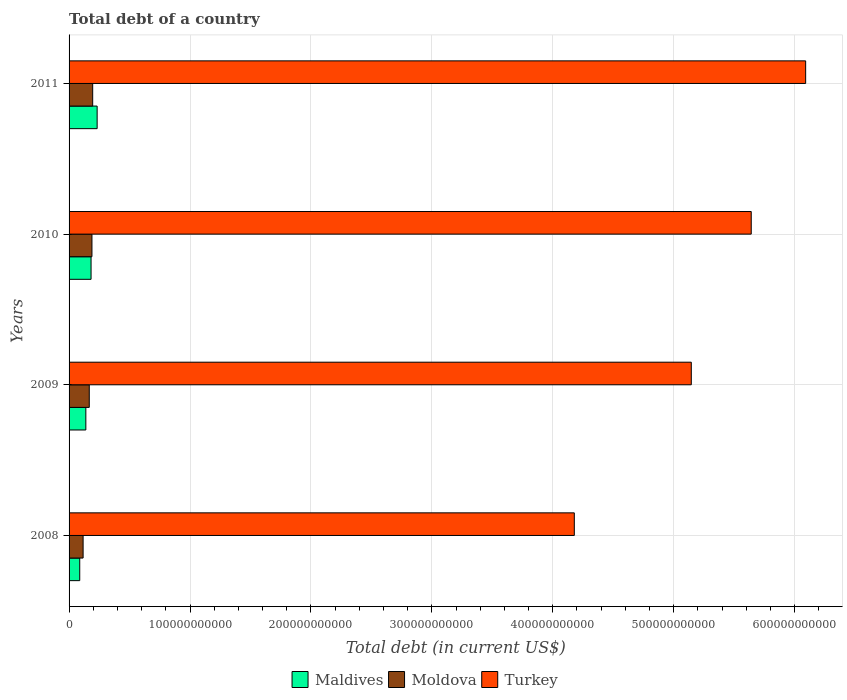How many different coloured bars are there?
Your answer should be very brief. 3. Are the number of bars per tick equal to the number of legend labels?
Make the answer very short. Yes. Are the number of bars on each tick of the Y-axis equal?
Provide a short and direct response. Yes. How many bars are there on the 4th tick from the top?
Make the answer very short. 3. How many bars are there on the 2nd tick from the bottom?
Your answer should be compact. 3. In how many cases, is the number of bars for a given year not equal to the number of legend labels?
Provide a succinct answer. 0. What is the debt in Maldives in 2010?
Offer a very short reply. 1.82e+1. Across all years, what is the maximum debt in Turkey?
Provide a short and direct response. 6.09e+11. Across all years, what is the minimum debt in Maldives?
Provide a succinct answer. 8.82e+09. What is the total debt in Maldives in the graph?
Ensure brevity in your answer.  6.41e+1. What is the difference between the debt in Moldova in 2008 and that in 2011?
Your answer should be compact. -7.92e+09. What is the difference between the debt in Moldova in 2009 and the debt in Turkey in 2011?
Provide a short and direct response. -5.92e+11. What is the average debt in Maldives per year?
Your answer should be very brief. 1.60e+1. In the year 2011, what is the difference between the debt in Maldives and debt in Turkey?
Give a very brief answer. -5.86e+11. What is the ratio of the debt in Maldives in 2008 to that in 2010?
Your answer should be very brief. 0.49. What is the difference between the highest and the second highest debt in Turkey?
Your response must be concise. 4.50e+1. What is the difference between the highest and the lowest debt in Maldives?
Ensure brevity in your answer.  1.44e+1. In how many years, is the debt in Turkey greater than the average debt in Turkey taken over all years?
Provide a short and direct response. 2. Is the sum of the debt in Maldives in 2008 and 2011 greater than the maximum debt in Moldova across all years?
Give a very brief answer. Yes. What does the 3rd bar from the top in 2009 represents?
Make the answer very short. Maldives. What does the 2nd bar from the bottom in 2008 represents?
Offer a terse response. Moldova. Is it the case that in every year, the sum of the debt in Moldova and debt in Maldives is greater than the debt in Turkey?
Offer a terse response. No. How many bars are there?
Your answer should be very brief. 12. Are all the bars in the graph horizontal?
Your answer should be very brief. Yes. What is the difference between two consecutive major ticks on the X-axis?
Your answer should be very brief. 1.00e+11. How are the legend labels stacked?
Provide a succinct answer. Horizontal. What is the title of the graph?
Make the answer very short. Total debt of a country. What is the label or title of the X-axis?
Provide a short and direct response. Total debt (in current US$). What is the Total debt (in current US$) in Maldives in 2008?
Make the answer very short. 8.82e+09. What is the Total debt (in current US$) of Moldova in 2008?
Ensure brevity in your answer.  1.16e+1. What is the Total debt (in current US$) in Turkey in 2008?
Your response must be concise. 4.18e+11. What is the Total debt (in current US$) in Maldives in 2009?
Keep it short and to the point. 1.39e+1. What is the Total debt (in current US$) in Moldova in 2009?
Make the answer very short. 1.67e+1. What is the Total debt (in current US$) in Turkey in 2009?
Provide a short and direct response. 5.15e+11. What is the Total debt (in current US$) of Maldives in 2010?
Your answer should be compact. 1.82e+1. What is the Total debt (in current US$) of Moldova in 2010?
Provide a short and direct response. 1.89e+1. What is the Total debt (in current US$) in Turkey in 2010?
Your response must be concise. 5.64e+11. What is the Total debt (in current US$) in Maldives in 2011?
Offer a terse response. 2.32e+1. What is the Total debt (in current US$) of Moldova in 2011?
Your answer should be compact. 1.95e+1. What is the Total debt (in current US$) of Turkey in 2011?
Make the answer very short. 6.09e+11. Across all years, what is the maximum Total debt (in current US$) of Maldives?
Offer a terse response. 2.32e+1. Across all years, what is the maximum Total debt (in current US$) of Moldova?
Ensure brevity in your answer.  1.95e+1. Across all years, what is the maximum Total debt (in current US$) of Turkey?
Offer a terse response. 6.09e+11. Across all years, what is the minimum Total debt (in current US$) in Maldives?
Offer a terse response. 8.82e+09. Across all years, what is the minimum Total debt (in current US$) of Moldova?
Keep it short and to the point. 1.16e+1. Across all years, what is the minimum Total debt (in current US$) in Turkey?
Your answer should be compact. 4.18e+11. What is the total Total debt (in current US$) of Maldives in the graph?
Your answer should be very brief. 6.41e+1. What is the total Total debt (in current US$) of Moldova in the graph?
Ensure brevity in your answer.  6.67e+1. What is the total Total debt (in current US$) in Turkey in the graph?
Your answer should be compact. 2.11e+12. What is the difference between the Total debt (in current US$) of Maldives in 2008 and that in 2009?
Make the answer very short. -5.04e+09. What is the difference between the Total debt (in current US$) in Moldova in 2008 and that in 2009?
Provide a short and direct response. -5.09e+09. What is the difference between the Total debt (in current US$) in Turkey in 2008 and that in 2009?
Give a very brief answer. -9.67e+1. What is the difference between the Total debt (in current US$) of Maldives in 2008 and that in 2010?
Give a very brief answer. -9.36e+09. What is the difference between the Total debt (in current US$) in Moldova in 2008 and that in 2010?
Ensure brevity in your answer.  -7.32e+09. What is the difference between the Total debt (in current US$) in Turkey in 2008 and that in 2010?
Provide a short and direct response. -1.46e+11. What is the difference between the Total debt (in current US$) of Maldives in 2008 and that in 2011?
Give a very brief answer. -1.44e+1. What is the difference between the Total debt (in current US$) of Moldova in 2008 and that in 2011?
Your answer should be compact. -7.92e+09. What is the difference between the Total debt (in current US$) in Turkey in 2008 and that in 2011?
Keep it short and to the point. -1.91e+11. What is the difference between the Total debt (in current US$) of Maldives in 2009 and that in 2010?
Ensure brevity in your answer.  -4.32e+09. What is the difference between the Total debt (in current US$) of Moldova in 2009 and that in 2010?
Provide a short and direct response. -2.22e+09. What is the difference between the Total debt (in current US$) of Turkey in 2009 and that in 2010?
Offer a terse response. -4.96e+1. What is the difference between the Total debt (in current US$) of Maldives in 2009 and that in 2011?
Your response must be concise. -9.34e+09. What is the difference between the Total debt (in current US$) in Moldova in 2009 and that in 2011?
Provide a short and direct response. -2.83e+09. What is the difference between the Total debt (in current US$) of Turkey in 2009 and that in 2011?
Give a very brief answer. -9.46e+1. What is the difference between the Total debt (in current US$) in Maldives in 2010 and that in 2011?
Your response must be concise. -5.03e+09. What is the difference between the Total debt (in current US$) in Moldova in 2010 and that in 2011?
Your answer should be very brief. -6.02e+08. What is the difference between the Total debt (in current US$) of Turkey in 2010 and that in 2011?
Your response must be concise. -4.50e+1. What is the difference between the Total debt (in current US$) in Maldives in 2008 and the Total debt (in current US$) in Moldova in 2009?
Make the answer very short. -7.88e+09. What is the difference between the Total debt (in current US$) of Maldives in 2008 and the Total debt (in current US$) of Turkey in 2009?
Offer a terse response. -5.06e+11. What is the difference between the Total debt (in current US$) in Moldova in 2008 and the Total debt (in current US$) in Turkey in 2009?
Your answer should be very brief. -5.03e+11. What is the difference between the Total debt (in current US$) in Maldives in 2008 and the Total debt (in current US$) in Moldova in 2010?
Offer a terse response. -1.01e+1. What is the difference between the Total debt (in current US$) in Maldives in 2008 and the Total debt (in current US$) in Turkey in 2010?
Your answer should be compact. -5.55e+11. What is the difference between the Total debt (in current US$) in Moldova in 2008 and the Total debt (in current US$) in Turkey in 2010?
Keep it short and to the point. -5.53e+11. What is the difference between the Total debt (in current US$) of Maldives in 2008 and the Total debt (in current US$) of Moldova in 2011?
Ensure brevity in your answer.  -1.07e+1. What is the difference between the Total debt (in current US$) in Maldives in 2008 and the Total debt (in current US$) in Turkey in 2011?
Ensure brevity in your answer.  -6.00e+11. What is the difference between the Total debt (in current US$) in Moldova in 2008 and the Total debt (in current US$) in Turkey in 2011?
Provide a succinct answer. -5.98e+11. What is the difference between the Total debt (in current US$) in Maldives in 2009 and the Total debt (in current US$) in Moldova in 2010?
Your response must be concise. -5.06e+09. What is the difference between the Total debt (in current US$) of Maldives in 2009 and the Total debt (in current US$) of Turkey in 2010?
Keep it short and to the point. -5.50e+11. What is the difference between the Total debt (in current US$) in Moldova in 2009 and the Total debt (in current US$) in Turkey in 2010?
Offer a very short reply. -5.47e+11. What is the difference between the Total debt (in current US$) in Maldives in 2009 and the Total debt (in current US$) in Moldova in 2011?
Ensure brevity in your answer.  -5.66e+09. What is the difference between the Total debt (in current US$) of Maldives in 2009 and the Total debt (in current US$) of Turkey in 2011?
Make the answer very short. -5.95e+11. What is the difference between the Total debt (in current US$) in Moldova in 2009 and the Total debt (in current US$) in Turkey in 2011?
Your answer should be compact. -5.92e+11. What is the difference between the Total debt (in current US$) in Maldives in 2010 and the Total debt (in current US$) in Moldova in 2011?
Offer a very short reply. -1.34e+09. What is the difference between the Total debt (in current US$) of Maldives in 2010 and the Total debt (in current US$) of Turkey in 2011?
Give a very brief answer. -5.91e+11. What is the difference between the Total debt (in current US$) in Moldova in 2010 and the Total debt (in current US$) in Turkey in 2011?
Your answer should be very brief. -5.90e+11. What is the average Total debt (in current US$) in Maldives per year?
Provide a succinct answer. 1.60e+1. What is the average Total debt (in current US$) in Moldova per year?
Offer a very short reply. 1.67e+1. What is the average Total debt (in current US$) in Turkey per year?
Your answer should be very brief. 5.26e+11. In the year 2008, what is the difference between the Total debt (in current US$) in Maldives and Total debt (in current US$) in Moldova?
Provide a short and direct response. -2.78e+09. In the year 2008, what is the difference between the Total debt (in current US$) in Maldives and Total debt (in current US$) in Turkey?
Offer a terse response. -4.09e+11. In the year 2008, what is the difference between the Total debt (in current US$) in Moldova and Total debt (in current US$) in Turkey?
Offer a very short reply. -4.06e+11. In the year 2009, what is the difference between the Total debt (in current US$) in Maldives and Total debt (in current US$) in Moldova?
Give a very brief answer. -2.83e+09. In the year 2009, what is the difference between the Total debt (in current US$) in Maldives and Total debt (in current US$) in Turkey?
Keep it short and to the point. -5.01e+11. In the year 2009, what is the difference between the Total debt (in current US$) in Moldova and Total debt (in current US$) in Turkey?
Keep it short and to the point. -4.98e+11. In the year 2010, what is the difference between the Total debt (in current US$) in Maldives and Total debt (in current US$) in Moldova?
Give a very brief answer. -7.40e+08. In the year 2010, what is the difference between the Total debt (in current US$) in Maldives and Total debt (in current US$) in Turkey?
Your answer should be very brief. -5.46e+11. In the year 2010, what is the difference between the Total debt (in current US$) in Moldova and Total debt (in current US$) in Turkey?
Provide a short and direct response. -5.45e+11. In the year 2011, what is the difference between the Total debt (in current US$) in Maldives and Total debt (in current US$) in Moldova?
Offer a very short reply. 3.69e+09. In the year 2011, what is the difference between the Total debt (in current US$) in Maldives and Total debt (in current US$) in Turkey?
Give a very brief answer. -5.86e+11. In the year 2011, what is the difference between the Total debt (in current US$) in Moldova and Total debt (in current US$) in Turkey?
Your answer should be very brief. -5.90e+11. What is the ratio of the Total debt (in current US$) of Maldives in 2008 to that in 2009?
Ensure brevity in your answer.  0.64. What is the ratio of the Total debt (in current US$) of Moldova in 2008 to that in 2009?
Keep it short and to the point. 0.69. What is the ratio of the Total debt (in current US$) of Turkey in 2008 to that in 2009?
Offer a very short reply. 0.81. What is the ratio of the Total debt (in current US$) of Maldives in 2008 to that in 2010?
Your answer should be very brief. 0.49. What is the ratio of the Total debt (in current US$) in Moldova in 2008 to that in 2010?
Make the answer very short. 0.61. What is the ratio of the Total debt (in current US$) in Turkey in 2008 to that in 2010?
Make the answer very short. 0.74. What is the ratio of the Total debt (in current US$) of Maldives in 2008 to that in 2011?
Offer a very short reply. 0.38. What is the ratio of the Total debt (in current US$) in Moldova in 2008 to that in 2011?
Make the answer very short. 0.59. What is the ratio of the Total debt (in current US$) in Turkey in 2008 to that in 2011?
Provide a succinct answer. 0.69. What is the ratio of the Total debt (in current US$) of Maldives in 2009 to that in 2010?
Offer a terse response. 0.76. What is the ratio of the Total debt (in current US$) in Moldova in 2009 to that in 2010?
Ensure brevity in your answer.  0.88. What is the ratio of the Total debt (in current US$) of Turkey in 2009 to that in 2010?
Keep it short and to the point. 0.91. What is the ratio of the Total debt (in current US$) of Maldives in 2009 to that in 2011?
Provide a short and direct response. 0.6. What is the ratio of the Total debt (in current US$) in Moldova in 2009 to that in 2011?
Your response must be concise. 0.86. What is the ratio of the Total debt (in current US$) of Turkey in 2009 to that in 2011?
Your answer should be compact. 0.84. What is the ratio of the Total debt (in current US$) of Maldives in 2010 to that in 2011?
Offer a terse response. 0.78. What is the ratio of the Total debt (in current US$) in Moldova in 2010 to that in 2011?
Your answer should be compact. 0.97. What is the ratio of the Total debt (in current US$) of Turkey in 2010 to that in 2011?
Ensure brevity in your answer.  0.93. What is the difference between the highest and the second highest Total debt (in current US$) of Maldives?
Your response must be concise. 5.03e+09. What is the difference between the highest and the second highest Total debt (in current US$) in Moldova?
Ensure brevity in your answer.  6.02e+08. What is the difference between the highest and the second highest Total debt (in current US$) of Turkey?
Provide a short and direct response. 4.50e+1. What is the difference between the highest and the lowest Total debt (in current US$) of Maldives?
Your answer should be compact. 1.44e+1. What is the difference between the highest and the lowest Total debt (in current US$) of Moldova?
Offer a terse response. 7.92e+09. What is the difference between the highest and the lowest Total debt (in current US$) in Turkey?
Offer a very short reply. 1.91e+11. 